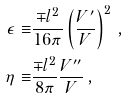<formula> <loc_0><loc_0><loc_500><loc_500>\epsilon \equiv & \frac { \mp l ^ { 2 } } { 1 6 \pi } \left ( \frac { V ^ { \prime } } { V } \right ) ^ { 2 } \, , \\ \eta \equiv & \frac { \mp l ^ { 2 } } { 8 \pi } \frac { V ^ { \prime \prime } } { V } \, ,</formula> 